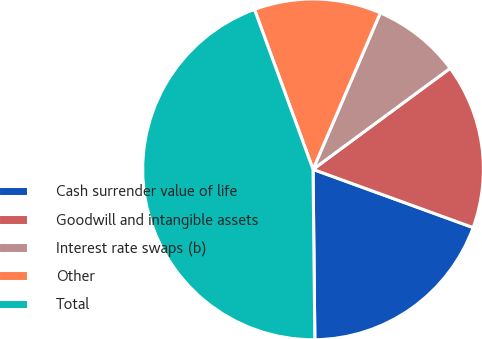Convert chart to OTSL. <chart><loc_0><loc_0><loc_500><loc_500><pie_chart><fcel>Cash surrender value of life<fcel>Goodwill and intangible assets<fcel>Interest rate swaps (b)<fcel>Other<fcel>Total<nl><fcel>19.28%<fcel>15.66%<fcel>8.43%<fcel>12.05%<fcel>44.58%<nl></chart> 